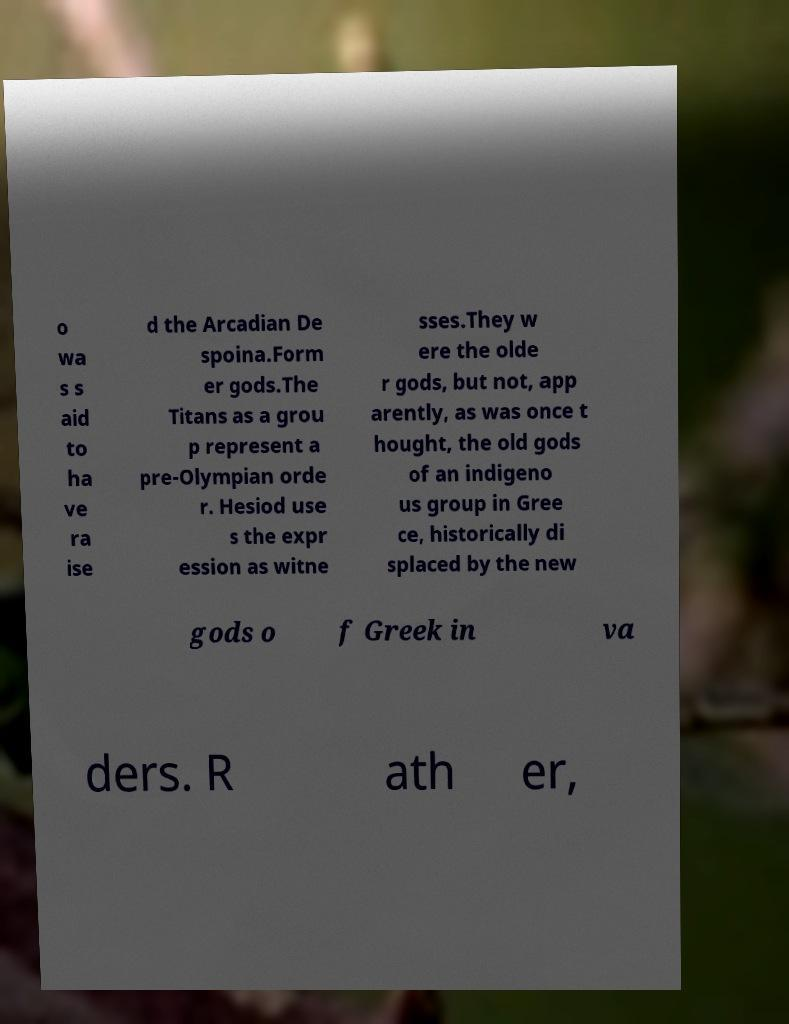Could you assist in decoding the text presented in this image and type it out clearly? o wa s s aid to ha ve ra ise d the Arcadian De spoina.Form er gods.The Titans as a grou p represent a pre-Olympian orde r. Hesiod use s the expr ession as witne sses.They w ere the olde r gods, but not, app arently, as was once t hought, the old gods of an indigeno us group in Gree ce, historically di splaced by the new gods o f Greek in va ders. R ath er, 